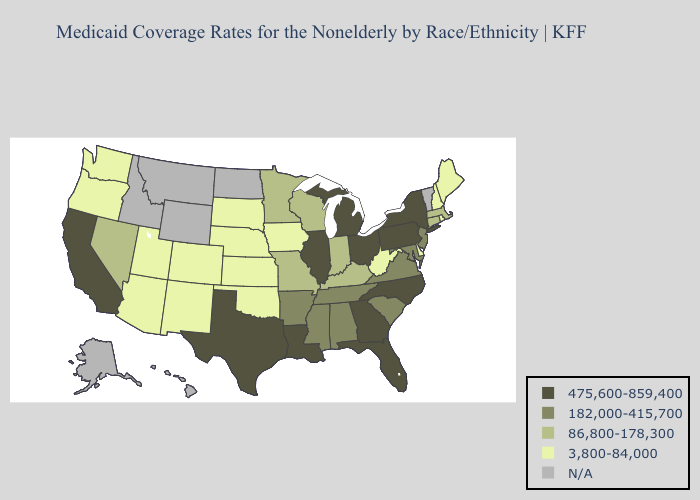Does Tennessee have the lowest value in the South?
Be succinct. No. Name the states that have a value in the range 475,600-859,400?
Concise answer only. California, Florida, Georgia, Illinois, Louisiana, Michigan, New York, North Carolina, Ohio, Pennsylvania, Texas. What is the lowest value in states that border Oregon?
Give a very brief answer. 3,800-84,000. What is the value of North Carolina?
Quick response, please. 475,600-859,400. Name the states that have a value in the range 475,600-859,400?
Answer briefly. California, Florida, Georgia, Illinois, Louisiana, Michigan, New York, North Carolina, Ohio, Pennsylvania, Texas. What is the value of Pennsylvania?
Concise answer only. 475,600-859,400. Does New York have the highest value in the Northeast?
Be succinct. Yes. Among the states that border Virginia , which have the highest value?
Quick response, please. North Carolina. Does the map have missing data?
Be succinct. Yes. Name the states that have a value in the range N/A?
Write a very short answer. Alaska, Hawaii, Idaho, Montana, North Dakota, Vermont, Wyoming. What is the highest value in the USA?
Be succinct. 475,600-859,400. What is the value of Kentucky?
Quick response, please. 86,800-178,300. Does the first symbol in the legend represent the smallest category?
Answer briefly. No. Does the first symbol in the legend represent the smallest category?
Concise answer only. No. What is the lowest value in states that border Kentucky?
Answer briefly. 3,800-84,000. 